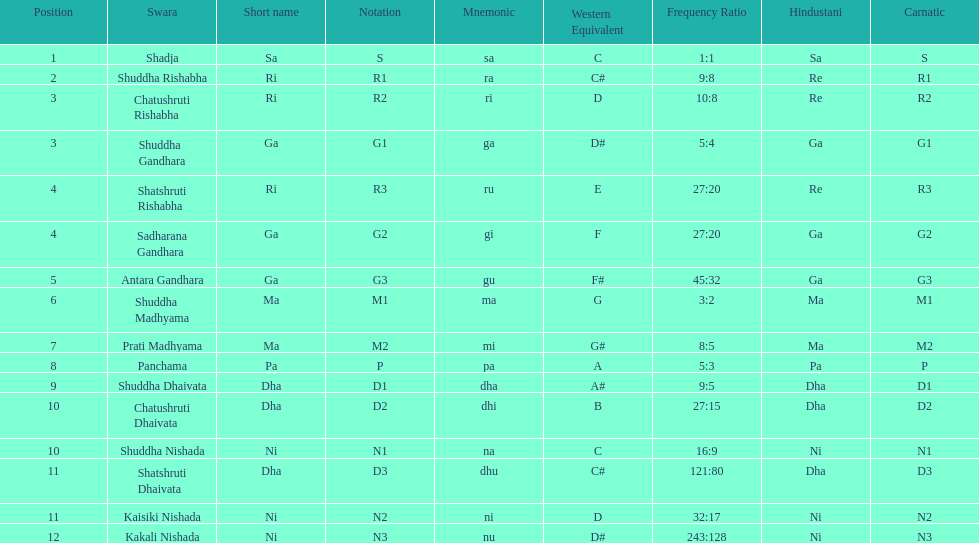What is the name of the swara that comes after panchama? Shuddha Dhaivata. 